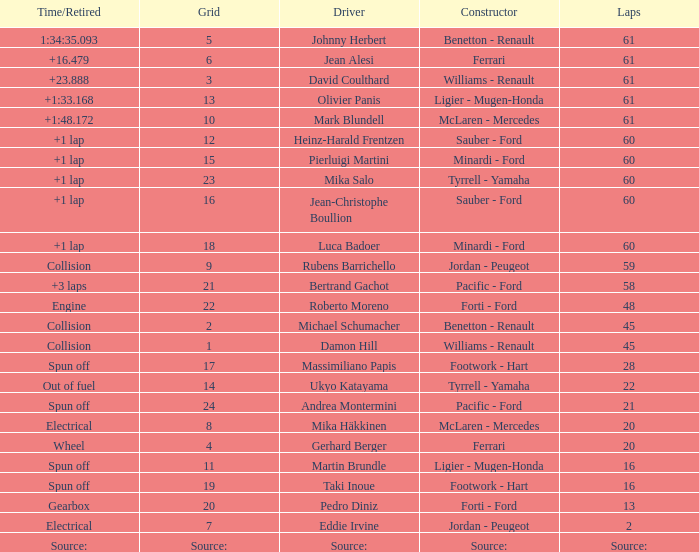How many laps does roberto moreno have? 48.0. 